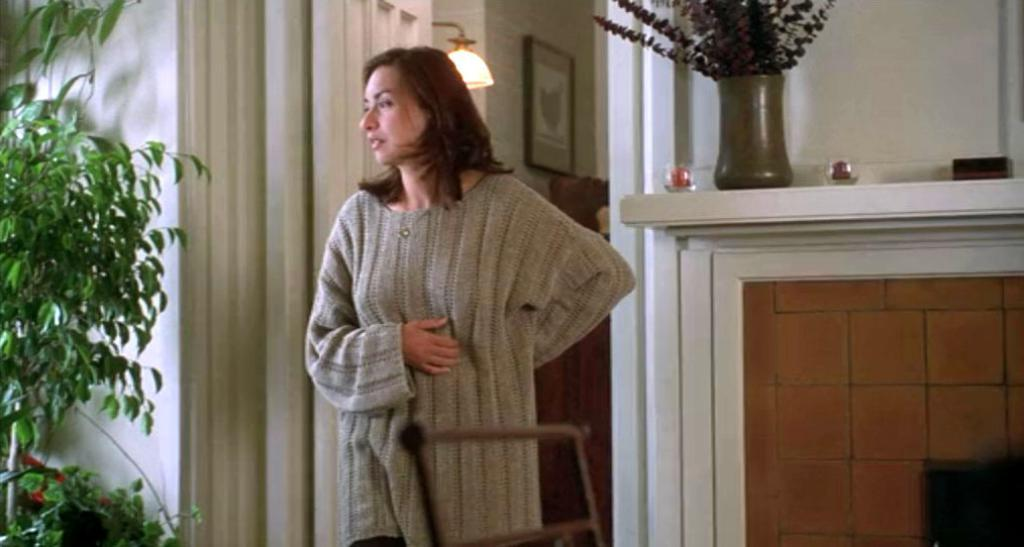What is located in the foreground of the image? There is a lady, a chair, and a plant in the foreground of the image. What can be seen in the background of the image? There are windows, framed objects, and other objects in the background of the image. What type of window treatment is present in the background of the image? There are curtains in the background of the image. How does the lady plan her voyage in the image? There is no indication in the image that the lady is planning a voyage, as the focus is on the lady, chair, and plant in the foreground. What type of elbow is visible in the image? There is no elbow visible in the image; it features a lady, a chair, and a plant in the foreground. 